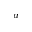<formula> <loc_0><loc_0><loc_500><loc_500>^ { a }</formula> 